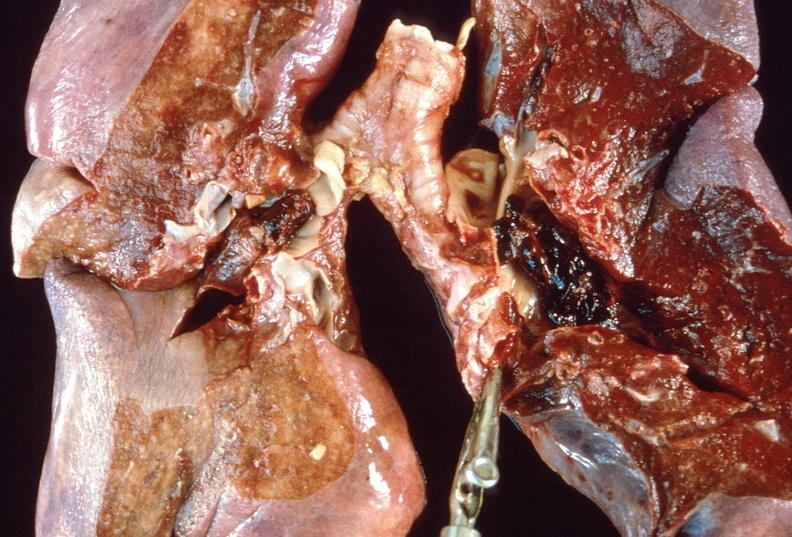s colon present?
Answer the question using a single word or phrase. No 